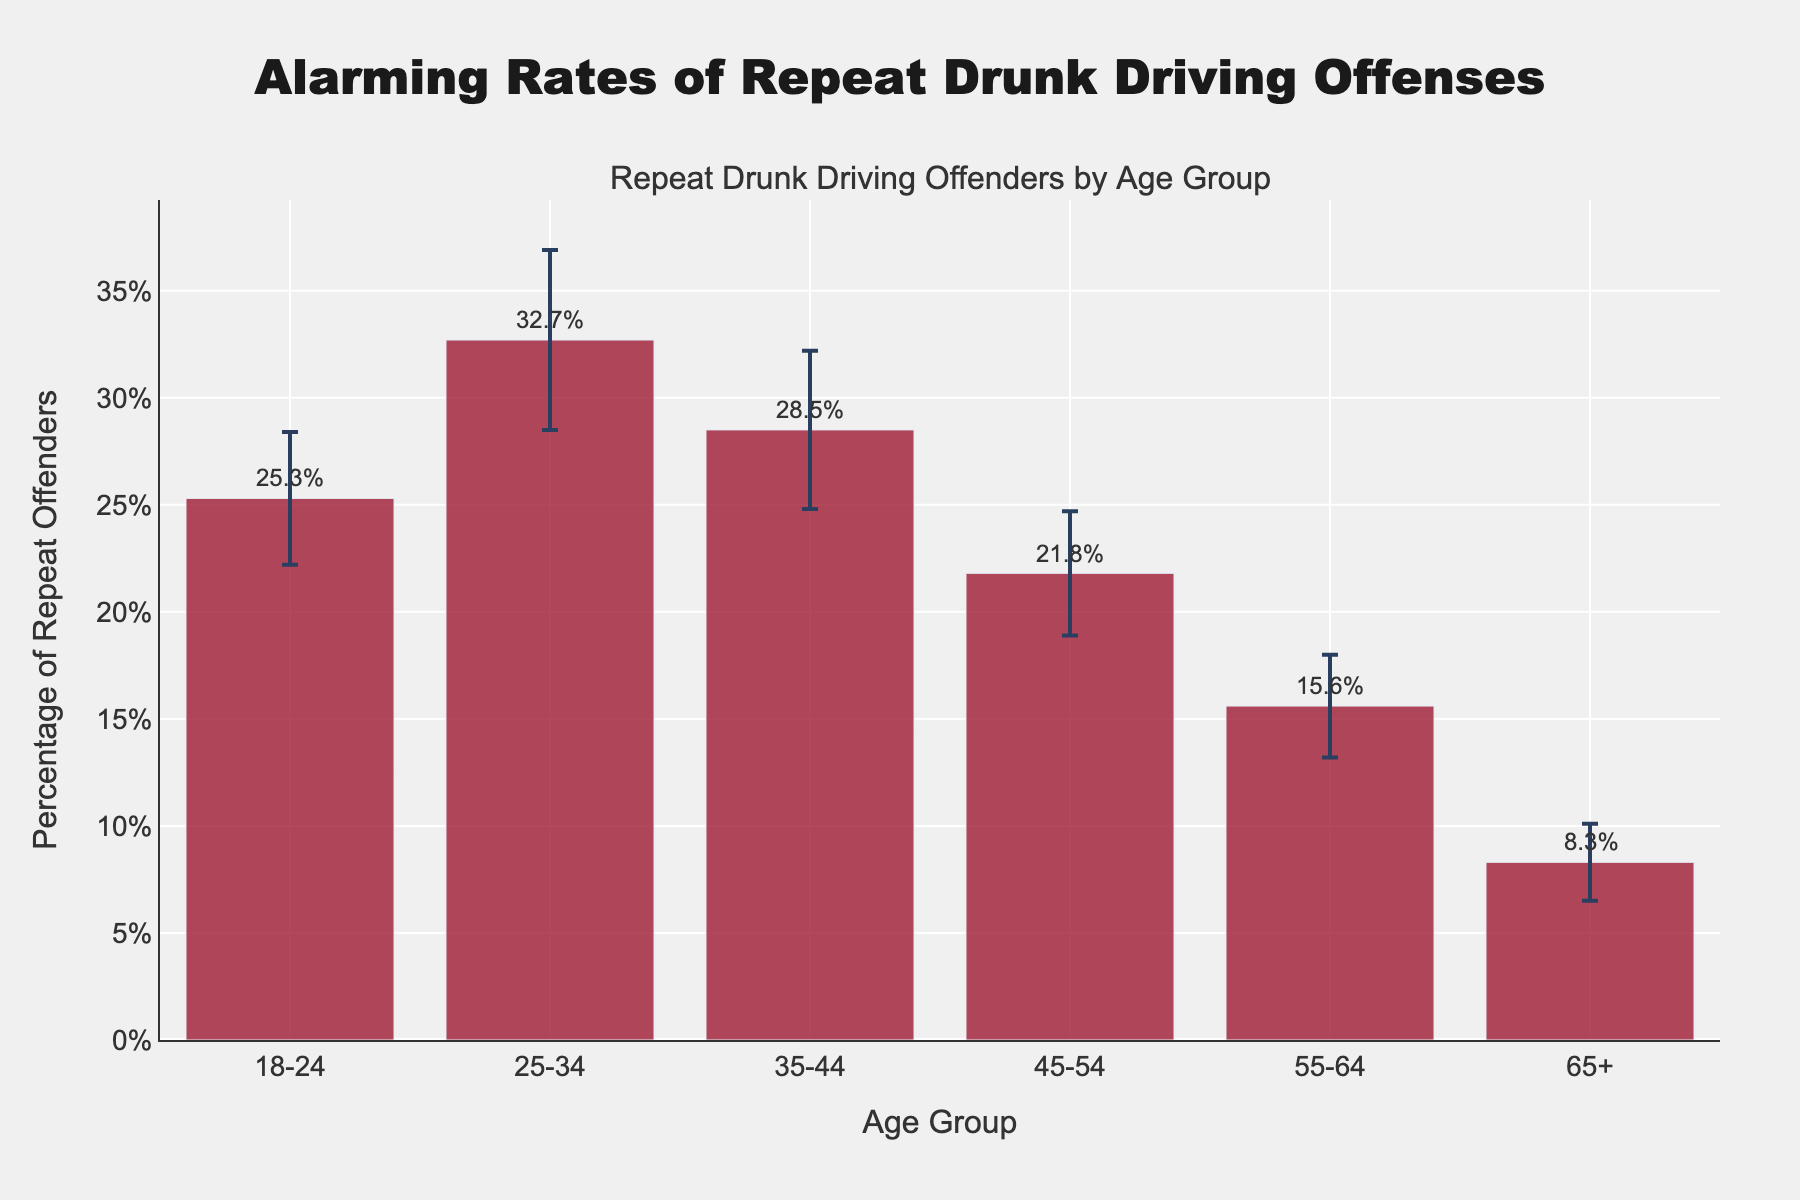What is the title of the plot? The title of the plot is located at the top and typically provides an overarching description of the visualized data. In this case, the title is "Alarming Rates of Repeat Drunk Driving Offenses".
Answer: Alarming Rates of Repeat Drunk Driving Offenses Which age group has the highest percentage of repeat drunk driving offenders? To answer this, refer to the tallest bar in the chart. The bar for the 25-34 age group is the tallest, indicating the highest percentage.
Answer: 25-34 What is the percentage of repeat offenders in the 45-54 age group? Look at the height of the bar corresponding to the 45-54 age group. The percentage is annotated and is also the height of the bar.
Answer: 21.8% Which age group has the lowest percentage of repeat drunk driving offenders? To determine the lowest percentage, look for the shortest bar on the plot, which corresponds to the 65+ age group.
Answer: 65+ What is the standard deviation for the 35-44 age group? Standard deviation is indicated by the error bars. For the 35-44 age group, the error bars represent a standard deviation of 3.7.
Answer: 3.7 How much higher is the percentage of repeat offenders in the 25-34 age group compared to the 18-24 age group? Subtract the percentage of the 18-24 group from the 25-34 group: 32.7% - 25.3% = 7.4%.
Answer: 7.4% Which age group has the largest error bar, indicating the highest uncertainty in percentage? Error bars represent standard deviation. Compare the lengths of the error bars; the longest corresponds to the highest standard deviation, which in this case is the 25-34 age group with an error bar of 4.2.
Answer: 25-34 What is the range of the y-axis? The range of the y-axis can be determined by observing the labeled values along the vertical y-axis, which extends from 0% to approximately 40%.
Answer: 0% to 40% How does the percentage of repeat offenders change as age increases from 18-24 to 65+? Observing the trend from left to right along the x-axis, the percentage tends to decrease as the age group increases.
Answer: Decreases Compare the percentages of repeat offenders between age groups 18-24 and 45-54. To compare the two age groups, subtract the percentage of 45-54 from 18-24: 25.3% - 21.8% = 3.5%. The 18-24 age group has 3.5% more repeat offenders than the 45-54 age group.
Answer: 3.5% 